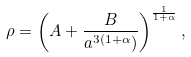<formula> <loc_0><loc_0><loc_500><loc_500>\rho = \left ( A + \frac { B } { a ^ { 3 ( 1 + \alpha } ) } \right ) ^ { \frac { 1 } { 1 + \alpha } } ,</formula> 